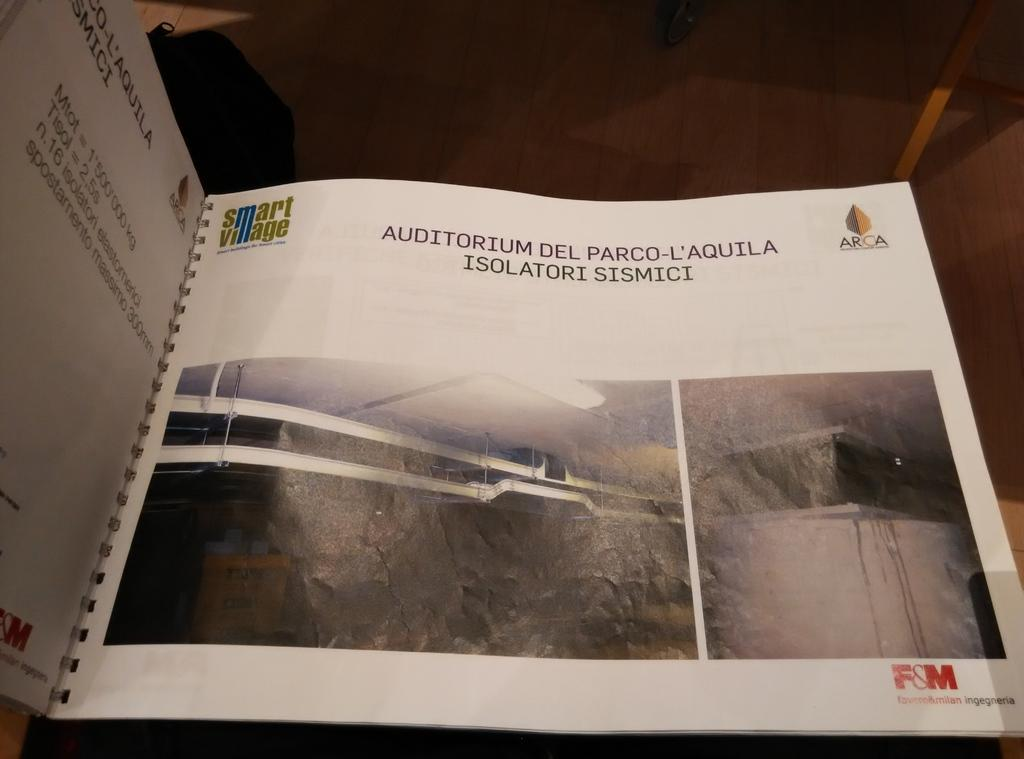<image>
Offer a succinct explanation of the picture presented. A book on the Auditorium del Parco-L'Awuila Isolatori Sismici. 